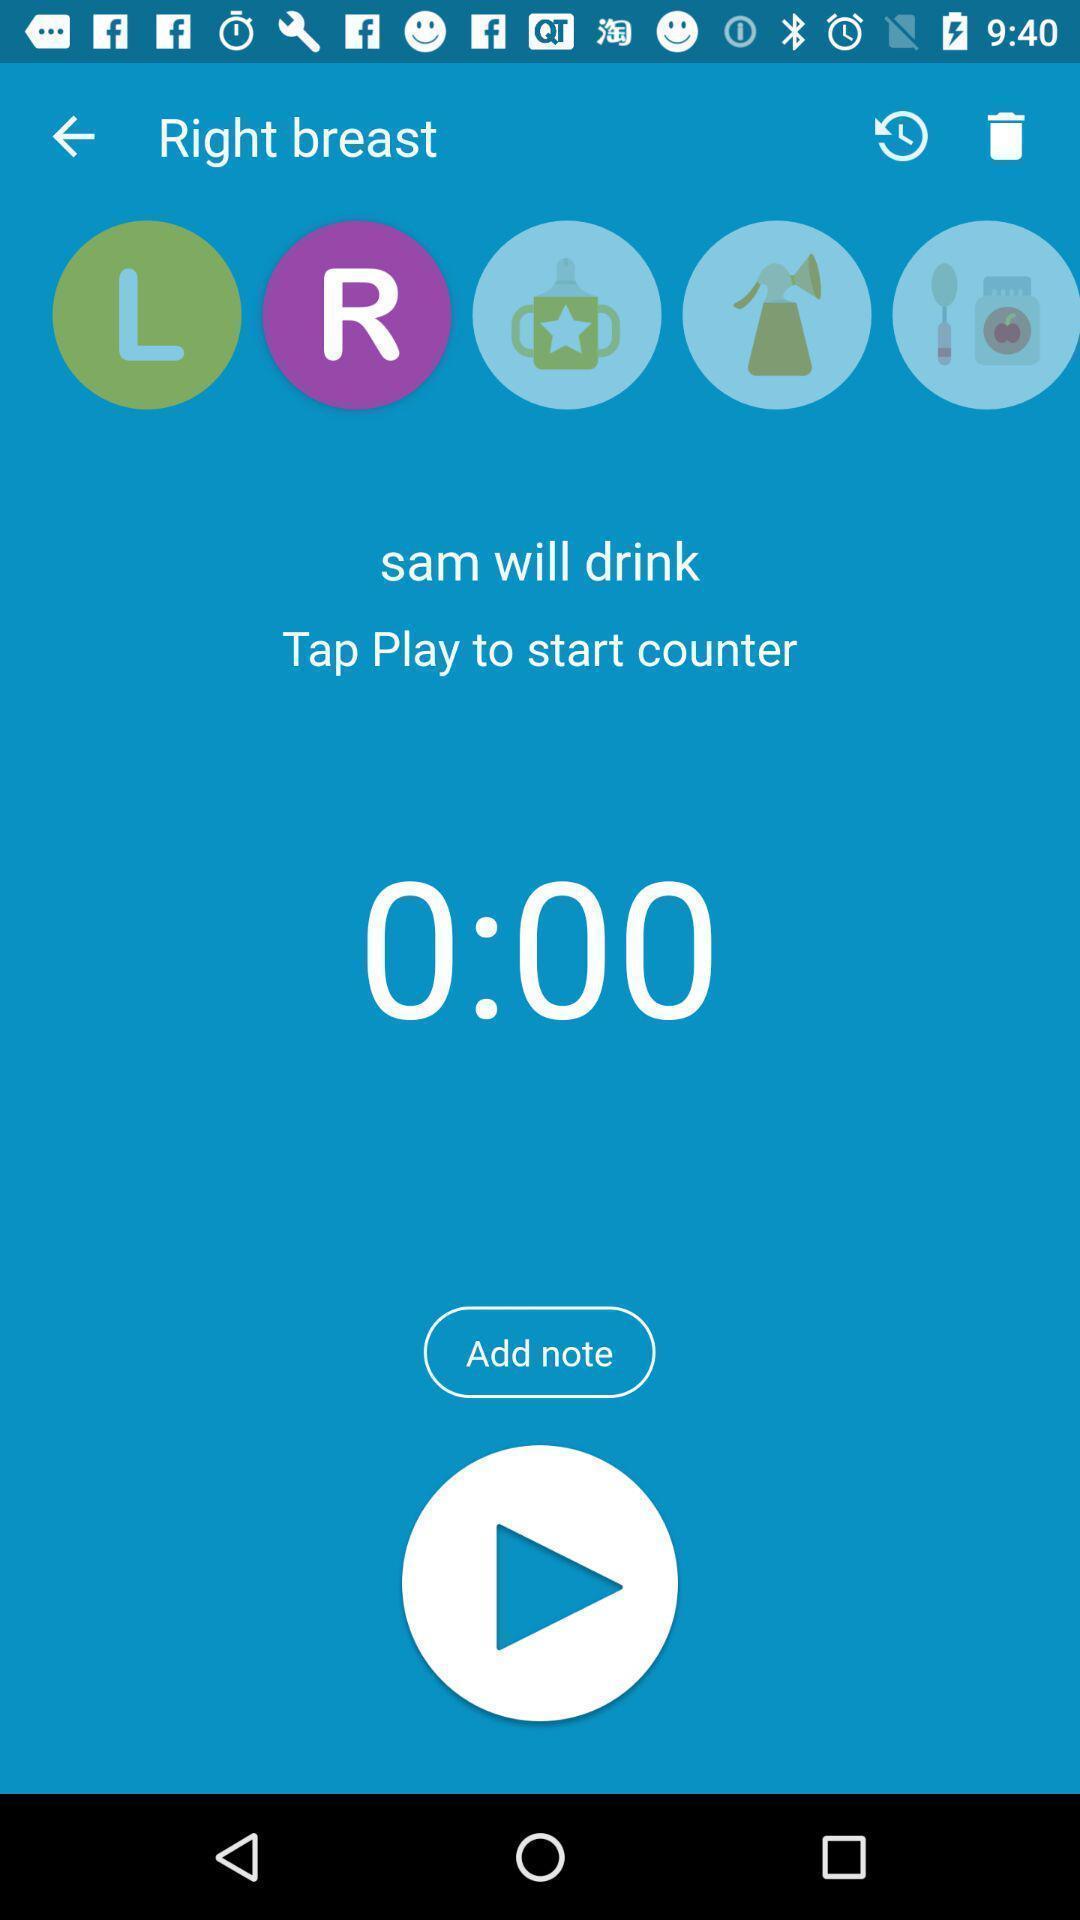Provide a detailed account of this screenshot. Stop clock page of the app. 